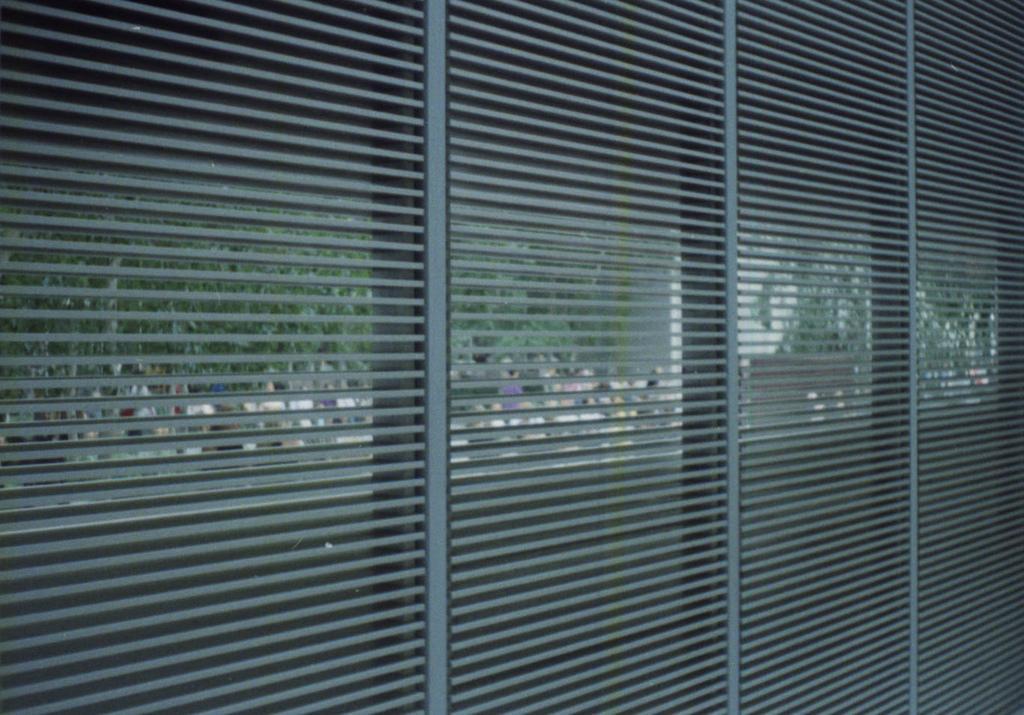In one or two sentences, can you explain what this image depicts? In this image I can see the window blind. In the background I can see few trees in green color. 